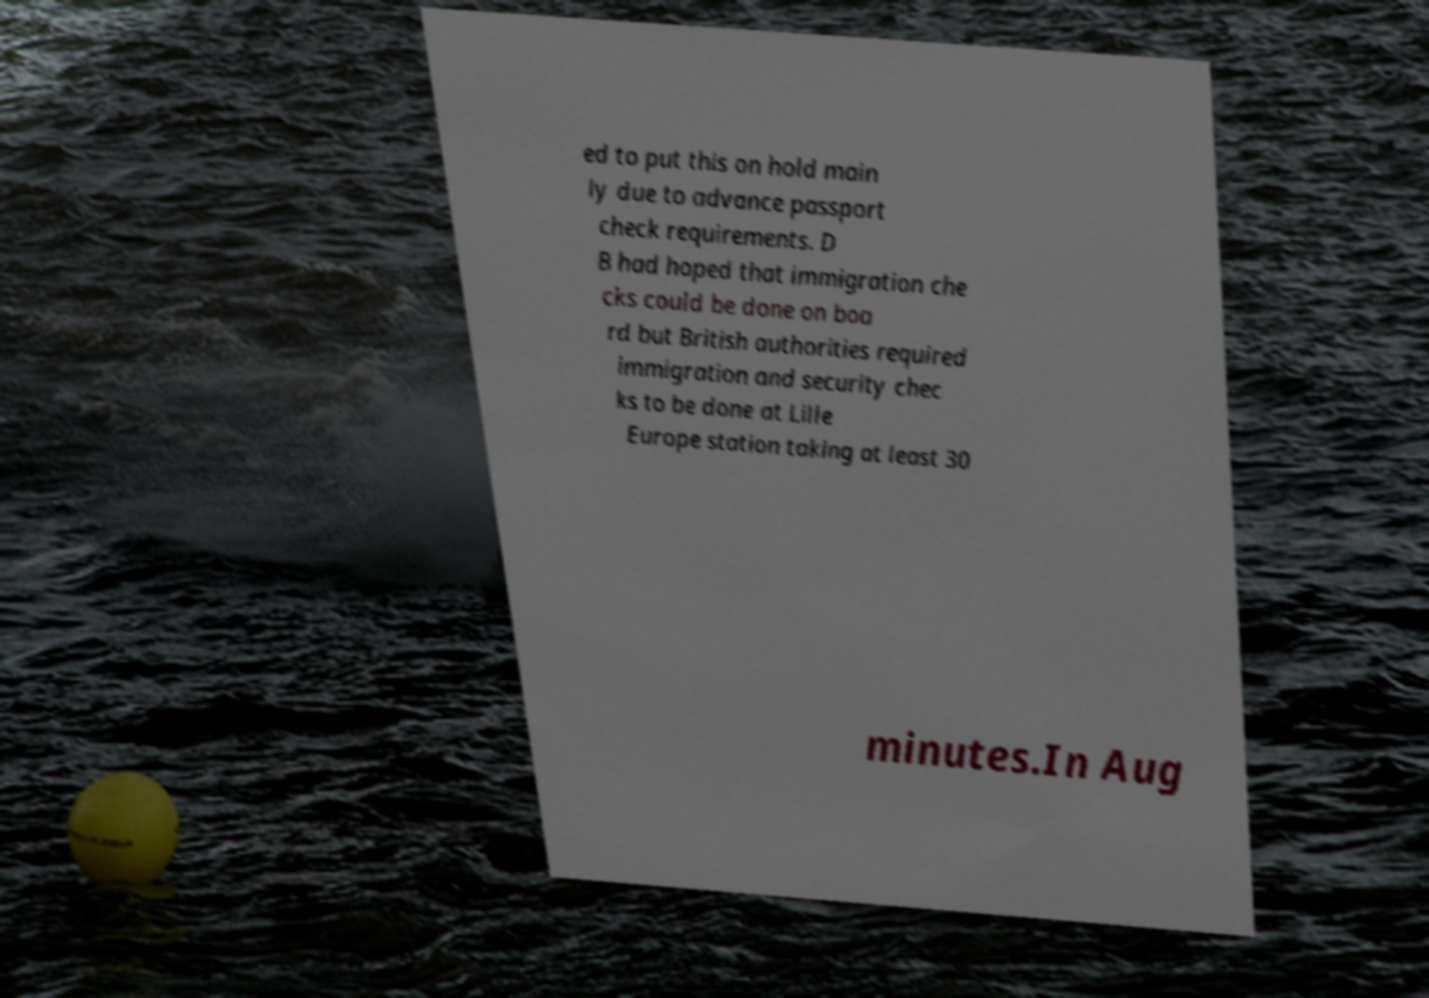Can you accurately transcribe the text from the provided image for me? ed to put this on hold main ly due to advance passport check requirements. D B had hoped that immigration che cks could be done on boa rd but British authorities required immigration and security chec ks to be done at Lille Europe station taking at least 30 minutes.In Aug 